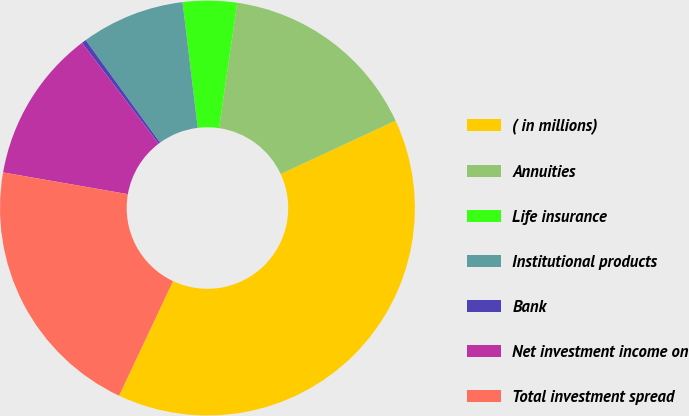<chart> <loc_0><loc_0><loc_500><loc_500><pie_chart><fcel>( in millions)<fcel>Annuities<fcel>Life insurance<fcel>Institutional products<fcel>Bank<fcel>Net investment income on<fcel>Total investment spread<nl><fcel>38.93%<fcel>15.78%<fcel>4.21%<fcel>8.07%<fcel>0.35%<fcel>11.92%<fcel>20.74%<nl></chart> 